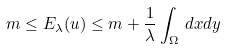<formula> <loc_0><loc_0><loc_500><loc_500>m \leq E _ { \lambda } ( u ) \leq m + \frac { 1 } { \lambda } \int _ { \Omega } \, d x d y</formula> 